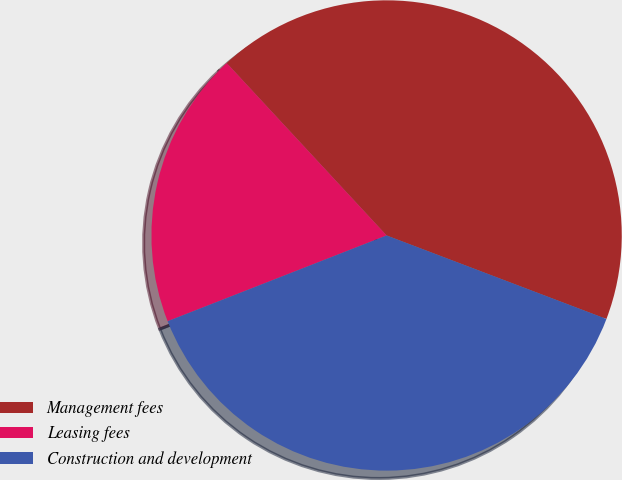<chart> <loc_0><loc_0><loc_500><loc_500><pie_chart><fcel>Management fees<fcel>Leasing fees<fcel>Construction and development<nl><fcel>42.68%<fcel>19.04%<fcel>38.28%<nl></chart> 